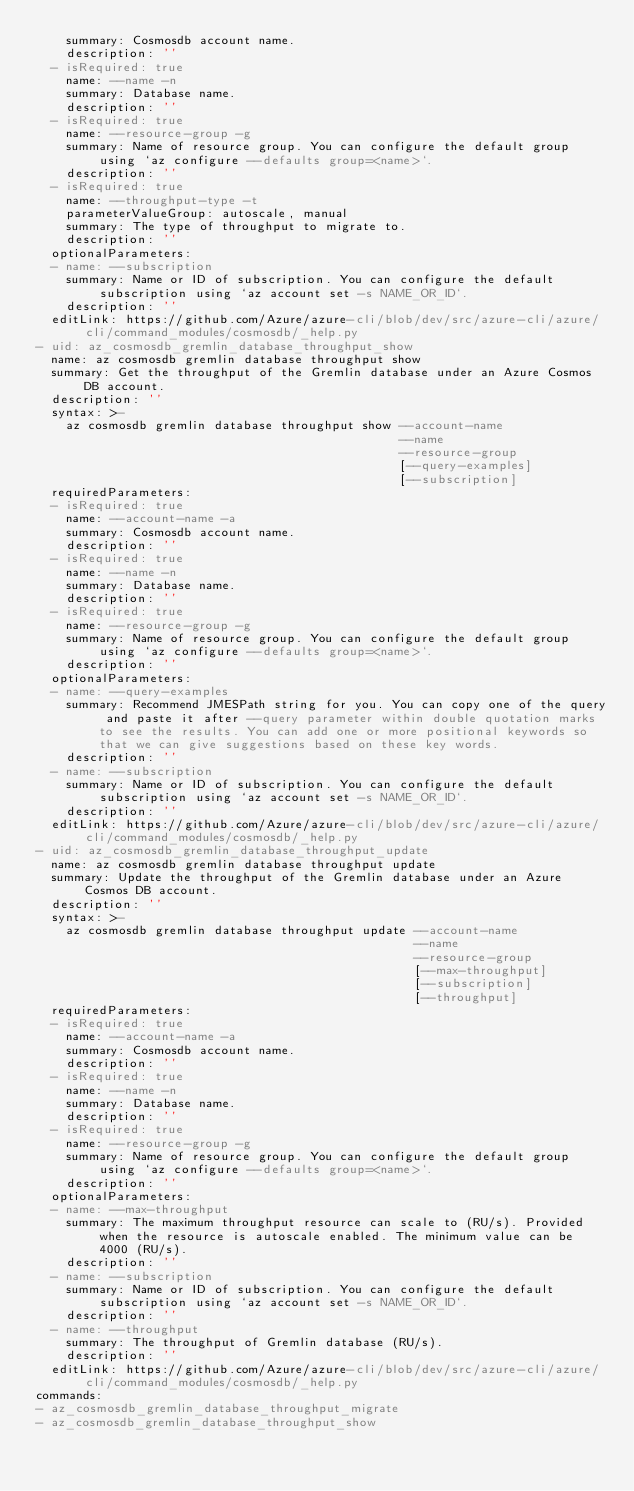<code> <loc_0><loc_0><loc_500><loc_500><_YAML_>    summary: Cosmosdb account name.
    description: ''
  - isRequired: true
    name: --name -n
    summary: Database name.
    description: ''
  - isRequired: true
    name: --resource-group -g
    summary: Name of resource group. You can configure the default group using `az configure --defaults group=<name>`.
    description: ''
  - isRequired: true
    name: --throughput-type -t
    parameterValueGroup: autoscale, manual
    summary: The type of throughput to migrate to.
    description: ''
  optionalParameters:
  - name: --subscription
    summary: Name or ID of subscription. You can configure the default subscription using `az account set -s NAME_OR_ID`.
    description: ''
  editLink: https://github.com/Azure/azure-cli/blob/dev/src/azure-cli/azure/cli/command_modules/cosmosdb/_help.py
- uid: az_cosmosdb_gremlin_database_throughput_show
  name: az cosmosdb gremlin database throughput show
  summary: Get the throughput of the Gremlin database under an Azure Cosmos DB account.
  description: ''
  syntax: >-
    az cosmosdb gremlin database throughput show --account-name
                                                 --name
                                                 --resource-group
                                                 [--query-examples]
                                                 [--subscription]
  requiredParameters:
  - isRequired: true
    name: --account-name -a
    summary: Cosmosdb account name.
    description: ''
  - isRequired: true
    name: --name -n
    summary: Database name.
    description: ''
  - isRequired: true
    name: --resource-group -g
    summary: Name of resource group. You can configure the default group using `az configure --defaults group=<name>`.
    description: ''
  optionalParameters:
  - name: --query-examples
    summary: Recommend JMESPath string for you. You can copy one of the query and paste it after --query parameter within double quotation marks to see the results. You can add one or more positional keywords so that we can give suggestions based on these key words.
    description: ''
  - name: --subscription
    summary: Name or ID of subscription. You can configure the default subscription using `az account set -s NAME_OR_ID`.
    description: ''
  editLink: https://github.com/Azure/azure-cli/blob/dev/src/azure-cli/azure/cli/command_modules/cosmosdb/_help.py
- uid: az_cosmosdb_gremlin_database_throughput_update
  name: az cosmosdb gremlin database throughput update
  summary: Update the throughput of the Gremlin database under an Azure Cosmos DB account.
  description: ''
  syntax: >-
    az cosmosdb gremlin database throughput update --account-name
                                                   --name
                                                   --resource-group
                                                   [--max-throughput]
                                                   [--subscription]
                                                   [--throughput]
  requiredParameters:
  - isRequired: true
    name: --account-name -a
    summary: Cosmosdb account name.
    description: ''
  - isRequired: true
    name: --name -n
    summary: Database name.
    description: ''
  - isRequired: true
    name: --resource-group -g
    summary: Name of resource group. You can configure the default group using `az configure --defaults group=<name>`.
    description: ''
  optionalParameters:
  - name: --max-throughput
    summary: The maximum throughput resource can scale to (RU/s). Provided when the resource is autoscale enabled. The minimum value can be 4000 (RU/s).
    description: ''
  - name: --subscription
    summary: Name or ID of subscription. You can configure the default subscription using `az account set -s NAME_OR_ID`.
    description: ''
  - name: --throughput
    summary: The throughput of Gremlin database (RU/s).
    description: ''
  editLink: https://github.com/Azure/azure-cli/blob/dev/src/azure-cli/azure/cli/command_modules/cosmosdb/_help.py
commands:
- az_cosmosdb_gremlin_database_throughput_migrate
- az_cosmosdb_gremlin_database_throughput_show</code> 